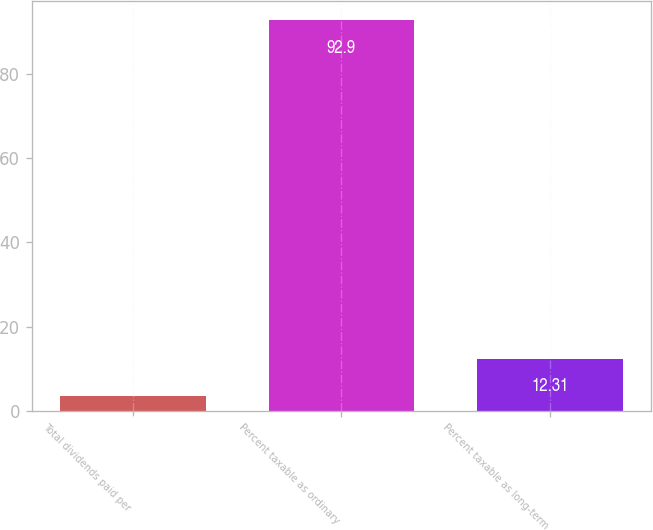Convert chart to OTSL. <chart><loc_0><loc_0><loc_500><loc_500><bar_chart><fcel>Total dividends paid per<fcel>Percent taxable as ordinary<fcel>Percent taxable as long-term<nl><fcel>3.36<fcel>92.9<fcel>12.31<nl></chart> 